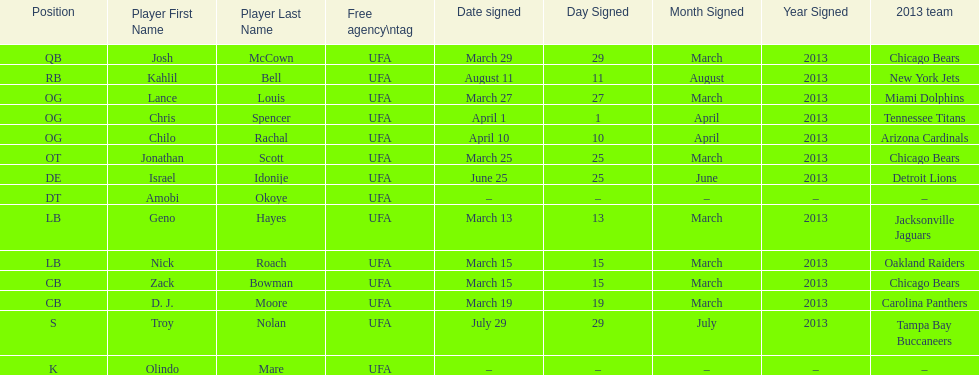How many players play cb or og? 5. 